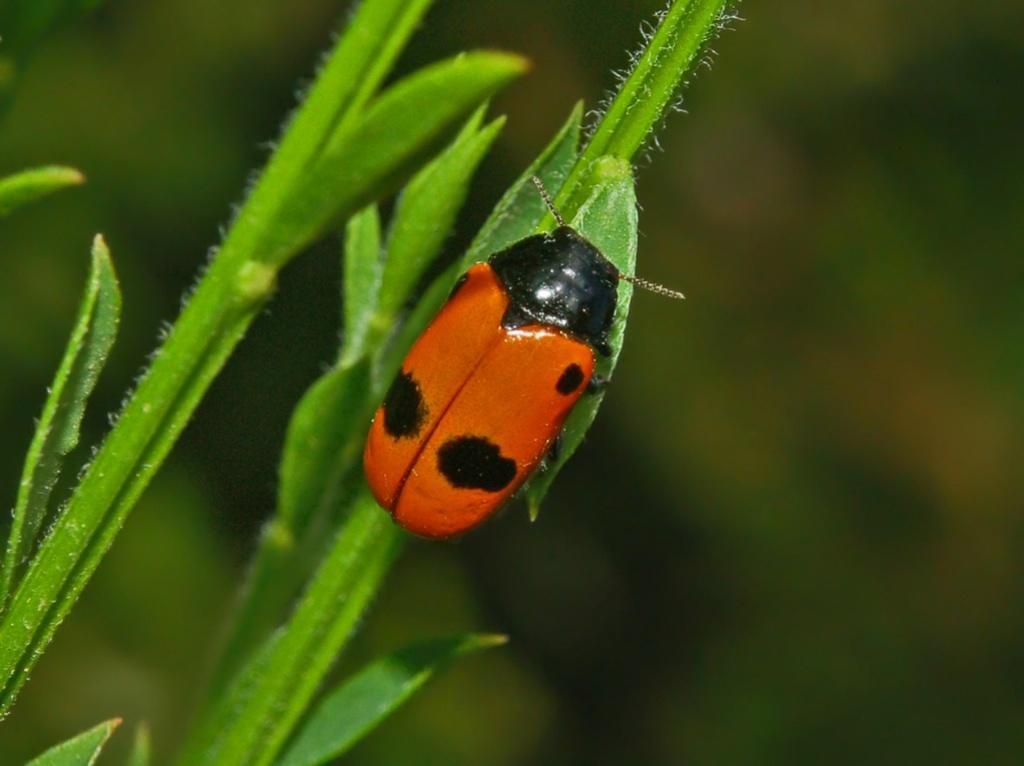How would you summarize this image in a sentence or two? In this picture we can see leaves on the left side, there is a bug on the leaf, we can see a blurry background. 